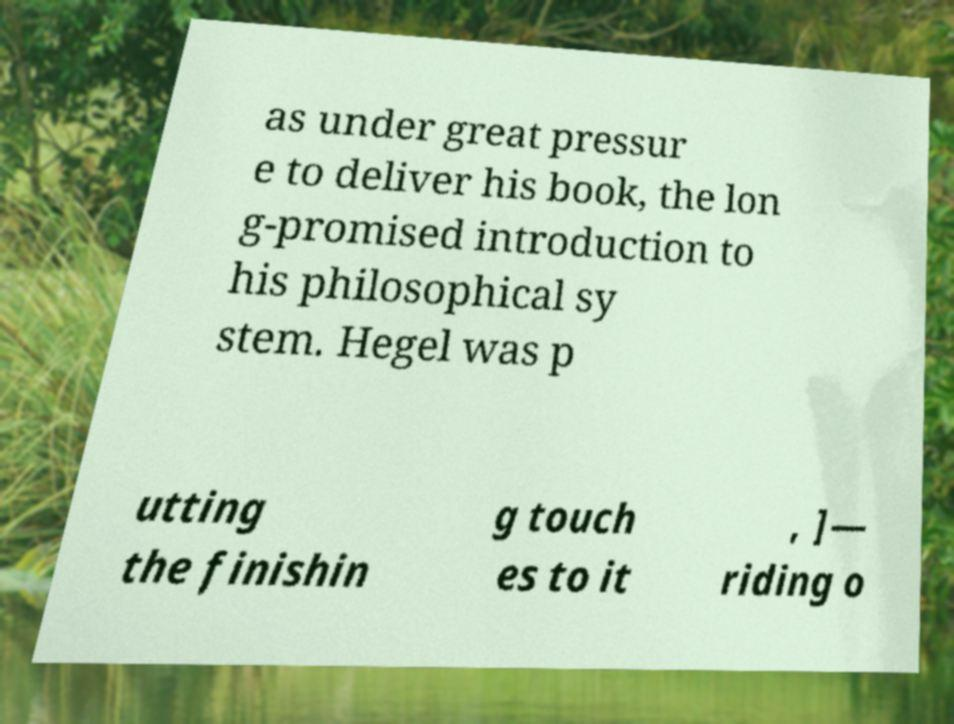Could you extract and type out the text from this image? as under great pressur e to deliver his book, the lon g-promised introduction to his philosophical sy stem. Hegel was p utting the finishin g touch es to it , ]— riding o 